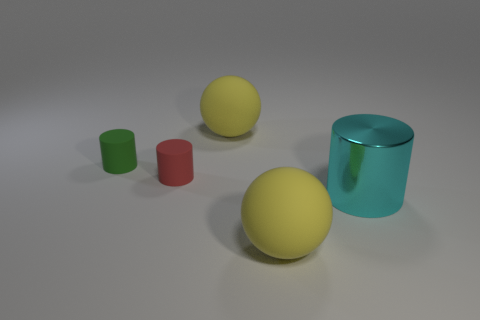How many objects are there in the image, and can you describe their colors? There are five objects in the image which include two large spheres, one yellow and one green; a small green cylinder; a small red cylinder; and a large cyan shiny cylinder. 